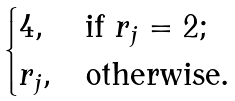<formula> <loc_0><loc_0><loc_500><loc_500>\begin{cases} 4 , & \text {if } r _ { j } = 2 ; \\ r _ { j } , & \text {otherwise.} \end{cases}</formula> 